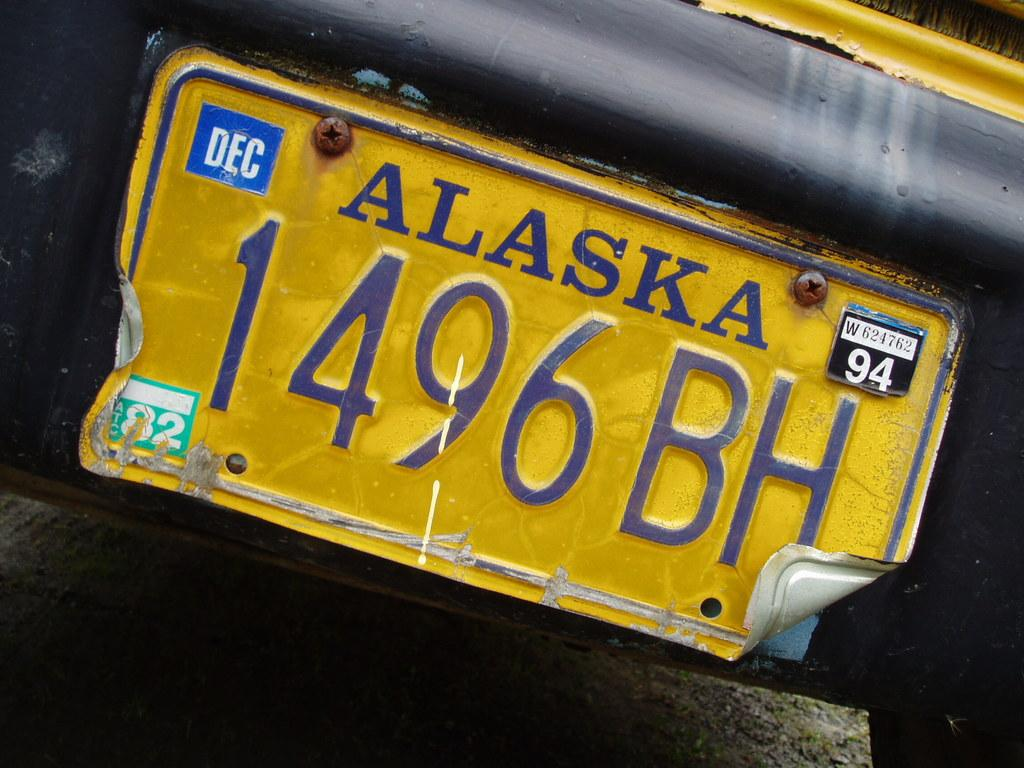<image>
Describe the image concisely. A yellow Alaska license plate reads 1496 BH with 94 in the right corner. 